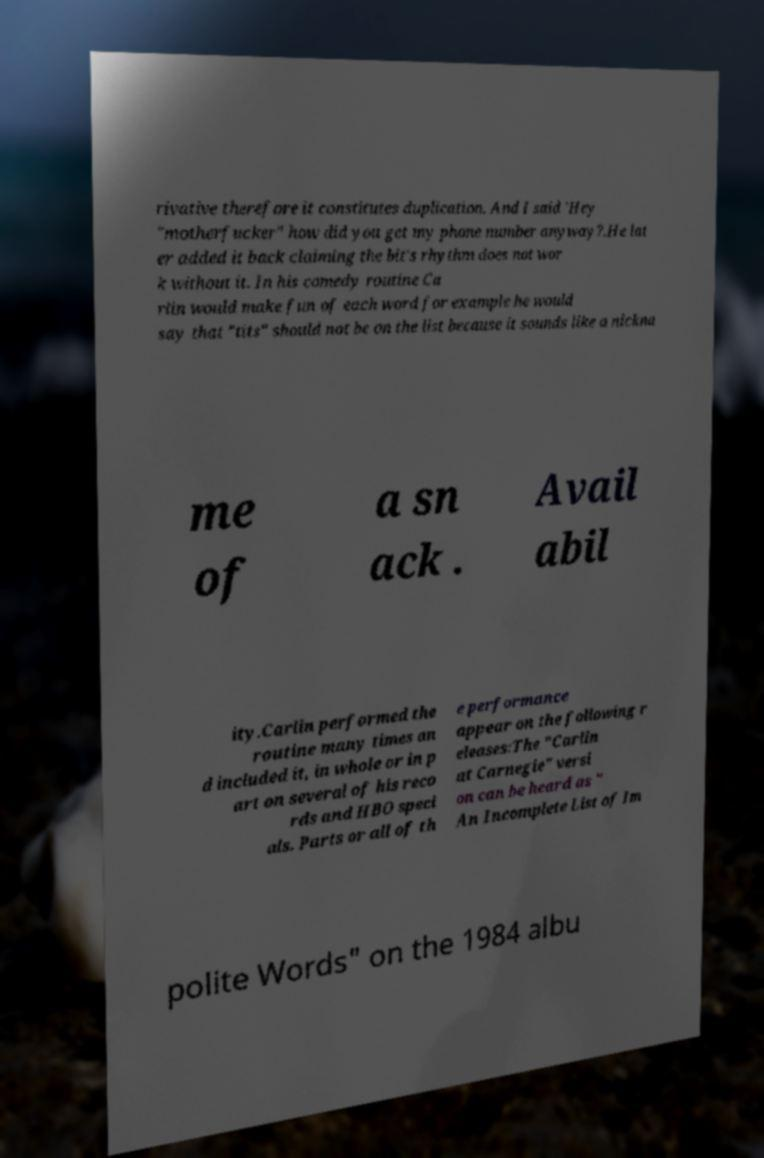What messages or text are displayed in this image? I need them in a readable, typed format. rivative therefore it constitutes duplication. And I said 'Hey "motherfucker" how did you get my phone number anyway?.He lat er added it back claiming the bit's rhythm does not wor k without it. In his comedy routine Ca rlin would make fun of each word for example he would say that "tits" should not be on the list because it sounds like a nickna me of a sn ack . Avail abil ity.Carlin performed the routine many times an d included it, in whole or in p art on several of his reco rds and HBO speci als. Parts or all of th e performance appear on the following r eleases:The "Carlin at Carnegie" versi on can be heard as " An Incomplete List of Im polite Words" on the 1984 albu 